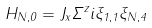Convert formula to latex. <formula><loc_0><loc_0><loc_500><loc_500>H _ { N , 0 } = J _ { x } \Sigma ^ { z } i \xi _ { 1 , 1 } \xi _ { N , 4 }</formula> 